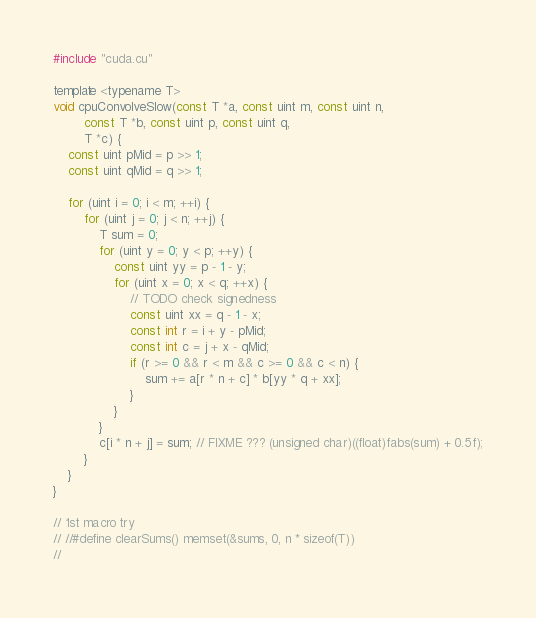Convert code to text. <code><loc_0><loc_0><loc_500><loc_500><_Cuda_>#include "cuda.cu"

template <typename T>
void cpuConvolveSlow(const T *a, const uint m, const uint n,
        const T *b, const uint p, const uint q,
        T *c) {
    const uint pMid = p >> 1;
    const uint qMid = q >> 1;

    for (uint i = 0; i < m; ++i) {
        for (uint j = 0; j < n; ++j) {
            T sum = 0;
            for (uint y = 0; y < p; ++y) {
                const uint yy = p - 1 - y;
                for (uint x = 0; x < q; ++x) {
                    // TODO check signedness
                    const uint xx = q - 1 - x;
                    const int r = i + y - pMid;
                    const int c = j + x - qMid;
                    if (r >= 0 && r < m && c >= 0 && c < n) {
                        sum += a[r * n + c] * b[yy * q + xx];
                    }
                }
            }
            c[i * n + j] = sum; // FIXME ??? (unsigned char)((float)fabs(sum) + 0.5f);
        }
    }
}

// 1st macro try
// //#define clearSums() memset(&sums, 0, n * sizeof(T))
//</code> 